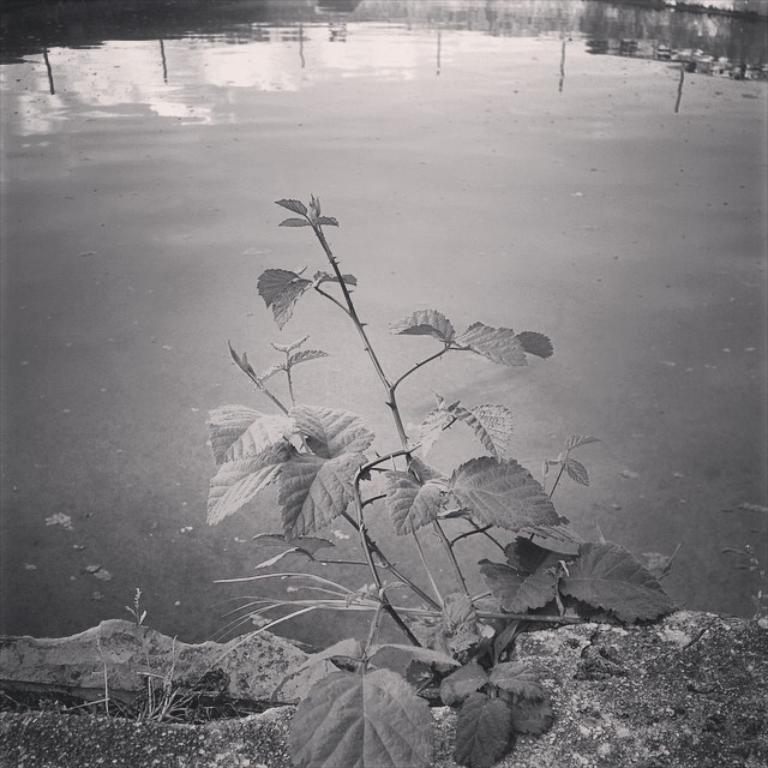What type of living organism can be seen in the image? There is a plant in the image. What else is present in the image besides the plant? There is water in the image. How many tigers can be seen playing on the floor in the image? There are no tigers or floors present in the image; it features a plant and water. 